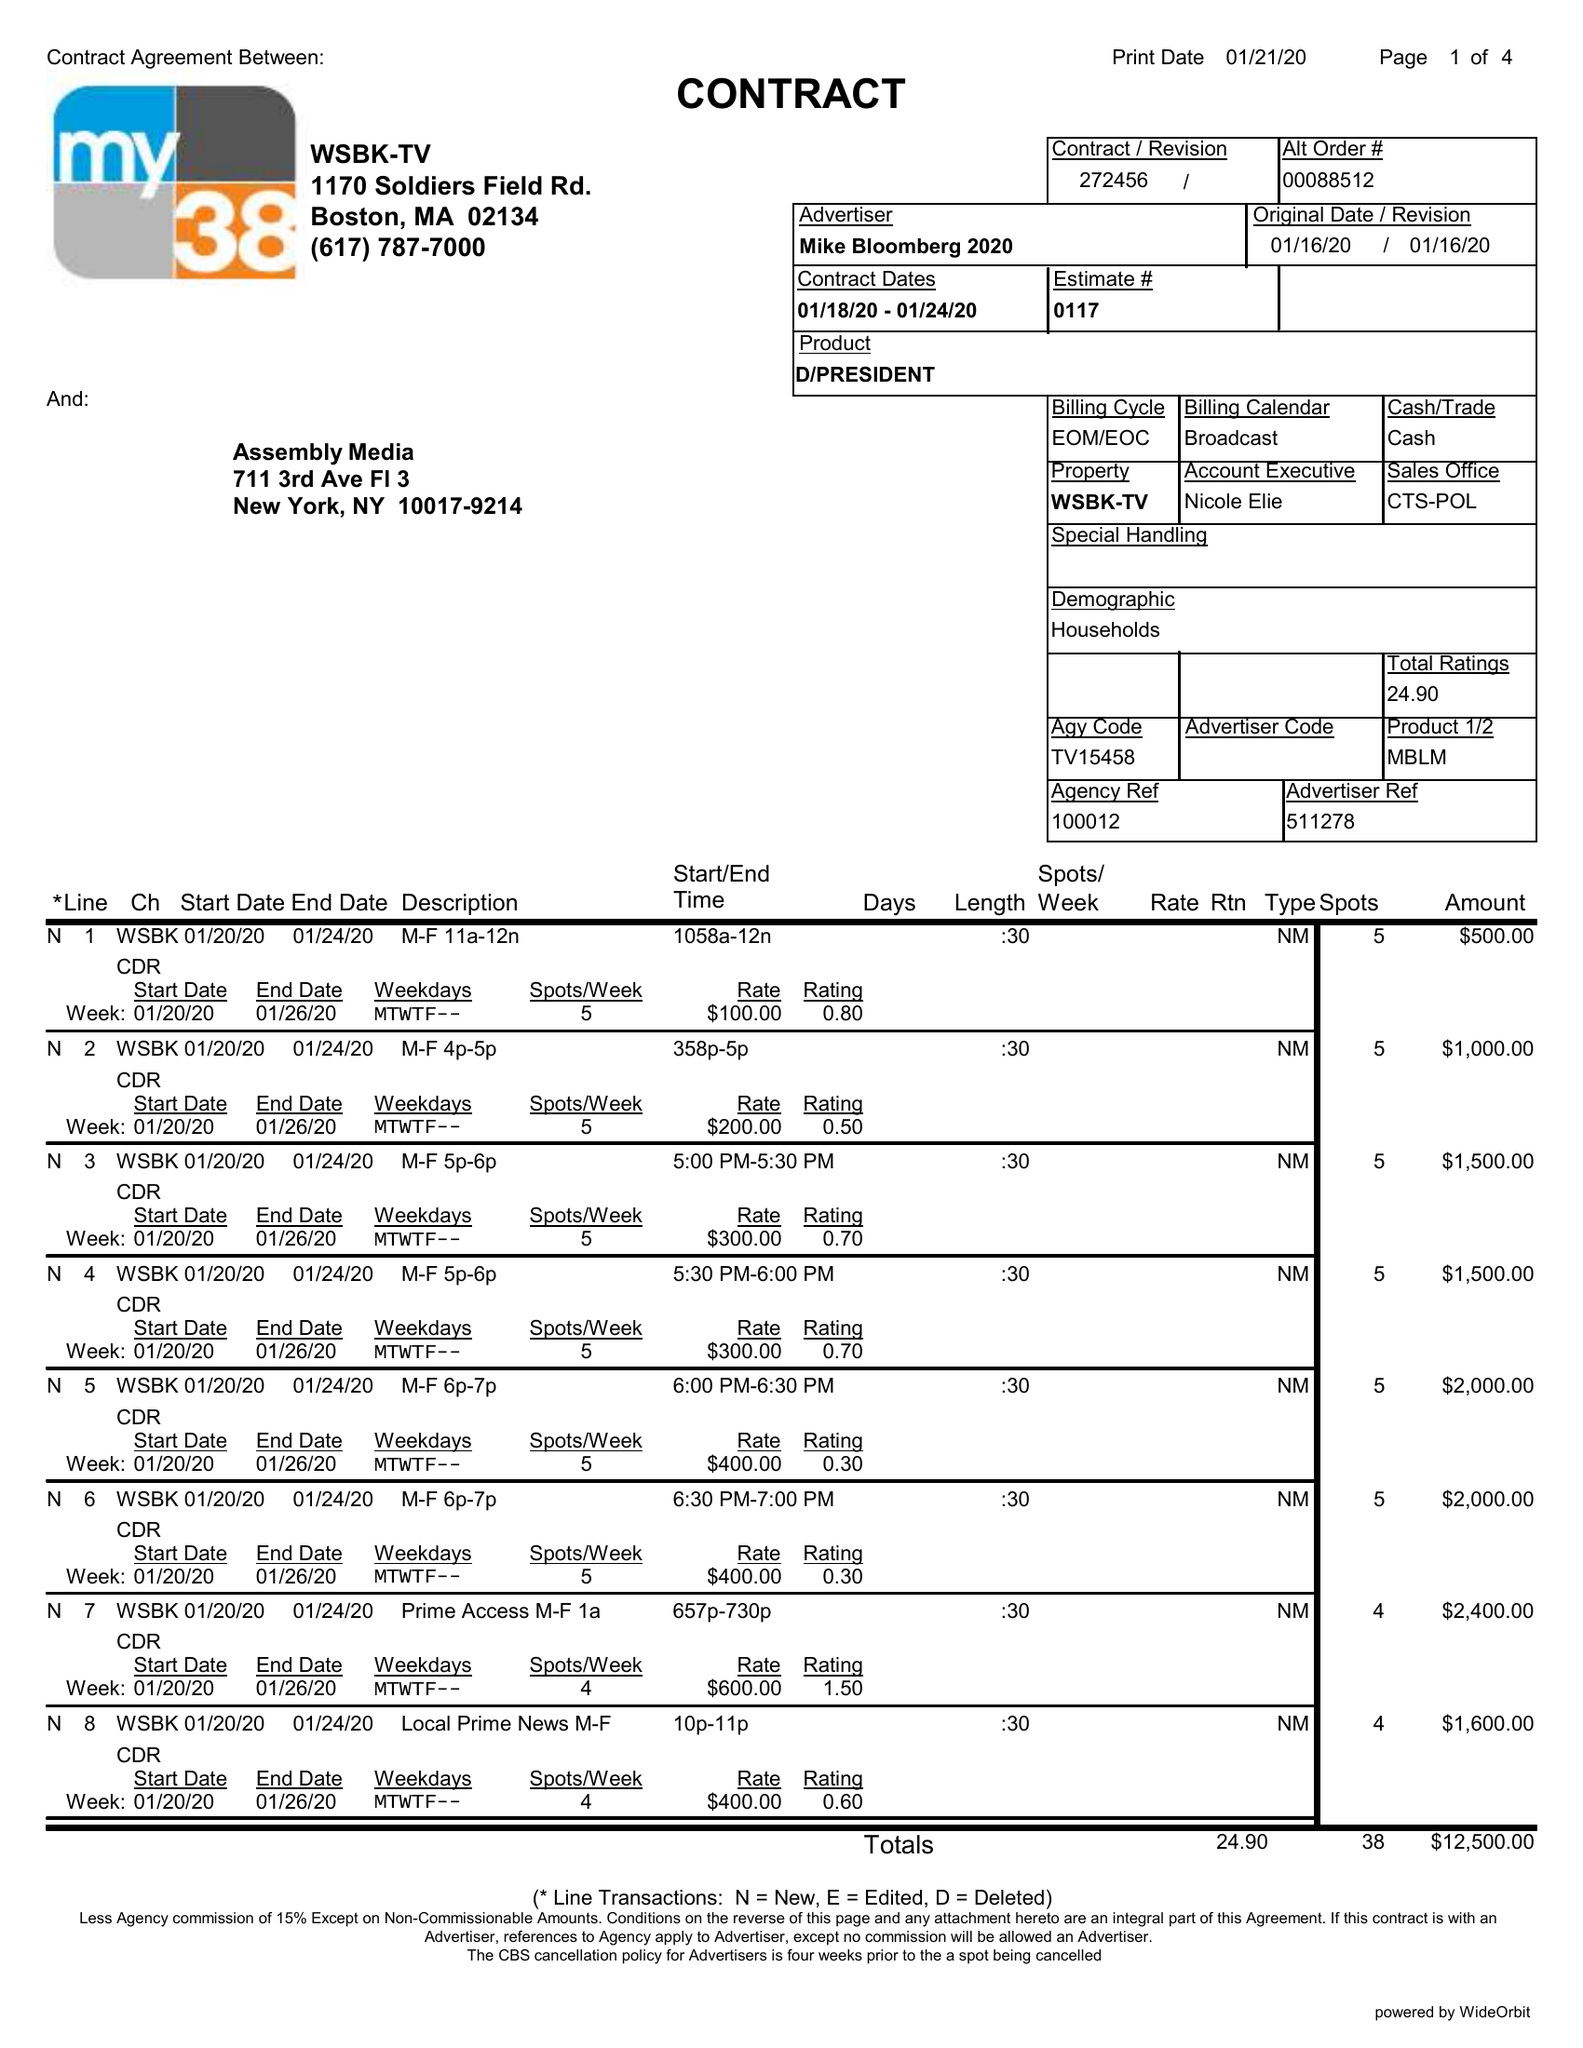What is the value for the contract_num?
Answer the question using a single word or phrase. 272456 